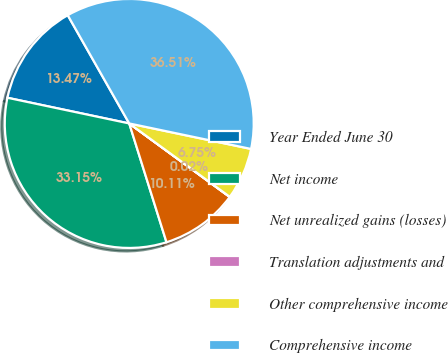Convert chart. <chart><loc_0><loc_0><loc_500><loc_500><pie_chart><fcel>Year Ended June 30<fcel>Net income<fcel>Net unrealized gains (losses)<fcel>Translation adjustments and<fcel>Other comprehensive income<fcel>Comprehensive income<nl><fcel>13.47%<fcel>33.15%<fcel>10.11%<fcel>0.02%<fcel>6.75%<fcel>36.51%<nl></chart> 